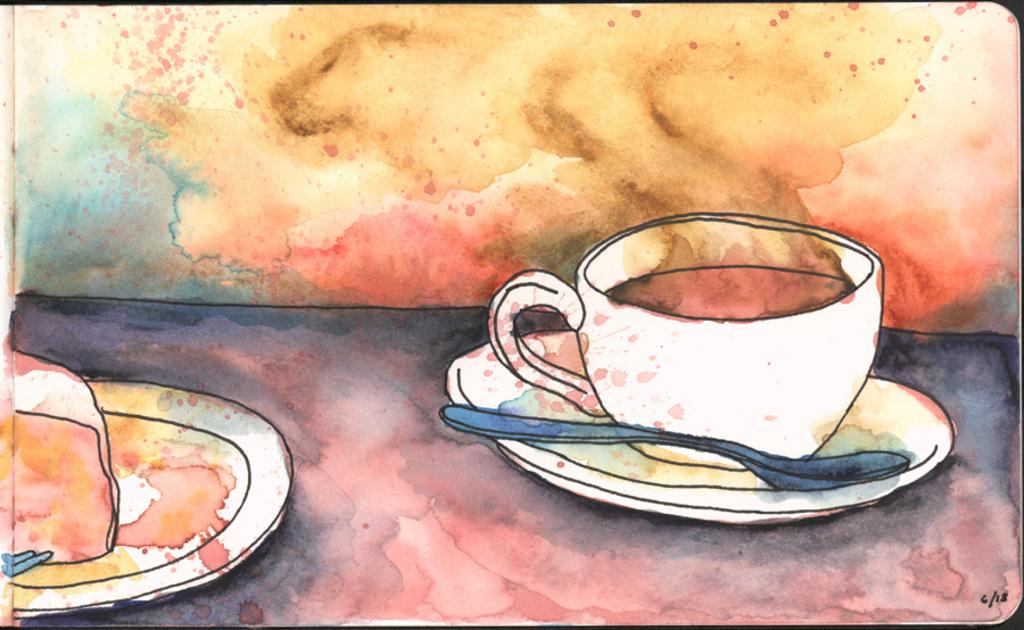What is the main subject of the image? There is a painting in the image. What is depicted in the painting? The painting depicts plates, a spoon, and a cup. What can be observed about the background of the painting? The background of the painting is colorful. Can you tell me how many firemen are present in the painting? There are no firemen depicted in the painting; it features plates, a spoon, and a cup. What type of sister is shown interacting with the plates in the painting? There is no sister present in the painting; it only includes plates, a spoon, and a cup. 